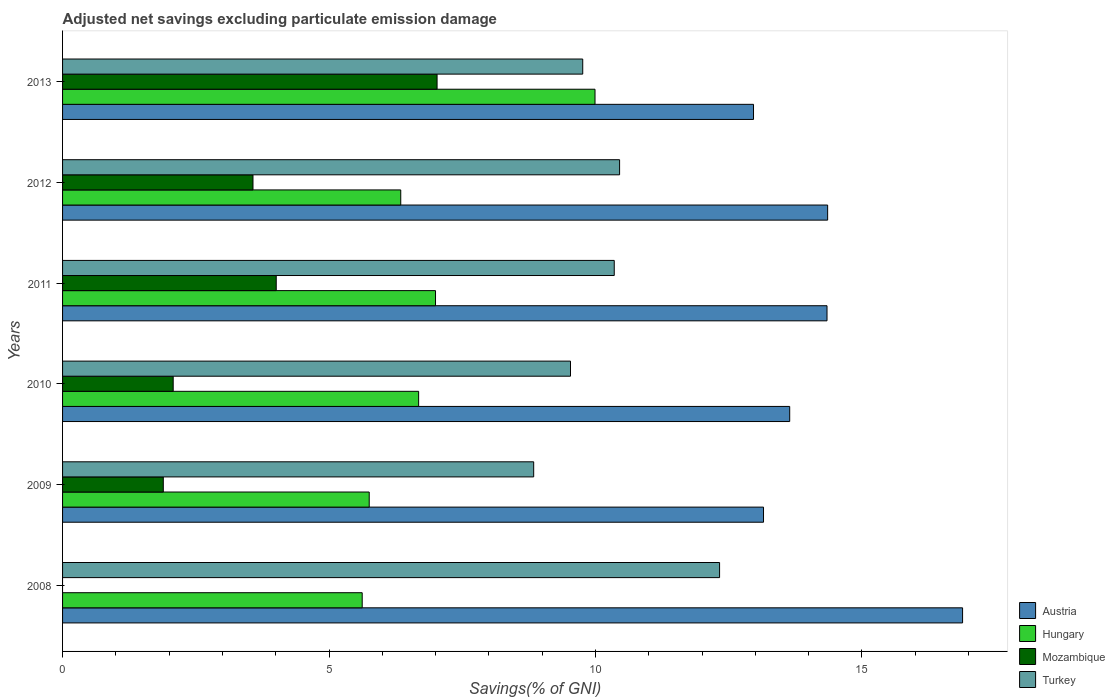How many different coloured bars are there?
Your answer should be very brief. 4. How many groups of bars are there?
Ensure brevity in your answer.  6. Are the number of bars on each tick of the Y-axis equal?
Your response must be concise. No. How many bars are there on the 4th tick from the top?
Your answer should be very brief. 4. How many bars are there on the 3rd tick from the bottom?
Make the answer very short. 4. What is the adjusted net savings in Hungary in 2012?
Make the answer very short. 6.35. Across all years, what is the maximum adjusted net savings in Mozambique?
Your response must be concise. 7.03. Across all years, what is the minimum adjusted net savings in Turkey?
Give a very brief answer. 8.84. In which year was the adjusted net savings in Mozambique maximum?
Offer a very short reply. 2013. What is the total adjusted net savings in Austria in the graph?
Keep it short and to the point. 85.36. What is the difference between the adjusted net savings in Austria in 2009 and that in 2012?
Your response must be concise. -1.2. What is the difference between the adjusted net savings in Austria in 2010 and the adjusted net savings in Mozambique in 2011?
Give a very brief answer. 9.64. What is the average adjusted net savings in Austria per year?
Provide a succinct answer. 14.23. In the year 2013, what is the difference between the adjusted net savings in Mozambique and adjusted net savings in Austria?
Your answer should be compact. -5.94. What is the ratio of the adjusted net savings in Mozambique in 2009 to that in 2011?
Provide a short and direct response. 0.47. Is the difference between the adjusted net savings in Mozambique in 2010 and 2013 greater than the difference between the adjusted net savings in Austria in 2010 and 2013?
Your response must be concise. No. What is the difference between the highest and the second highest adjusted net savings in Mozambique?
Provide a succinct answer. 3.02. What is the difference between the highest and the lowest adjusted net savings in Hungary?
Offer a very short reply. 4.37. In how many years, is the adjusted net savings in Hungary greater than the average adjusted net savings in Hungary taken over all years?
Keep it short and to the point. 2. Are all the bars in the graph horizontal?
Offer a very short reply. Yes. How many years are there in the graph?
Make the answer very short. 6. Are the values on the major ticks of X-axis written in scientific E-notation?
Offer a terse response. No. Where does the legend appear in the graph?
Your answer should be compact. Bottom right. How are the legend labels stacked?
Offer a very short reply. Vertical. What is the title of the graph?
Give a very brief answer. Adjusted net savings excluding particulate emission damage. What is the label or title of the X-axis?
Make the answer very short. Savings(% of GNI). What is the label or title of the Y-axis?
Your answer should be compact. Years. What is the Savings(% of GNI) in Austria in 2008?
Make the answer very short. 16.89. What is the Savings(% of GNI) in Hungary in 2008?
Give a very brief answer. 5.62. What is the Savings(% of GNI) in Mozambique in 2008?
Provide a short and direct response. 0. What is the Savings(% of GNI) of Turkey in 2008?
Your response must be concise. 12.33. What is the Savings(% of GNI) of Austria in 2009?
Your answer should be compact. 13.15. What is the Savings(% of GNI) of Hungary in 2009?
Ensure brevity in your answer.  5.75. What is the Savings(% of GNI) in Mozambique in 2009?
Provide a short and direct response. 1.89. What is the Savings(% of GNI) of Turkey in 2009?
Offer a very short reply. 8.84. What is the Savings(% of GNI) of Austria in 2010?
Provide a short and direct response. 13.64. What is the Savings(% of GNI) in Hungary in 2010?
Your answer should be very brief. 6.68. What is the Savings(% of GNI) in Mozambique in 2010?
Give a very brief answer. 2.08. What is the Savings(% of GNI) of Turkey in 2010?
Your response must be concise. 9.53. What is the Savings(% of GNI) of Austria in 2011?
Your answer should be very brief. 14.35. What is the Savings(% of GNI) in Hungary in 2011?
Ensure brevity in your answer.  7. What is the Savings(% of GNI) of Mozambique in 2011?
Make the answer very short. 4.01. What is the Savings(% of GNI) in Turkey in 2011?
Your answer should be compact. 10.35. What is the Savings(% of GNI) of Austria in 2012?
Give a very brief answer. 14.36. What is the Savings(% of GNI) of Hungary in 2012?
Offer a very short reply. 6.35. What is the Savings(% of GNI) in Mozambique in 2012?
Give a very brief answer. 3.57. What is the Savings(% of GNI) of Turkey in 2012?
Offer a terse response. 10.45. What is the Savings(% of GNI) of Austria in 2013?
Keep it short and to the point. 12.97. What is the Savings(% of GNI) of Hungary in 2013?
Ensure brevity in your answer.  9.99. What is the Savings(% of GNI) of Mozambique in 2013?
Ensure brevity in your answer.  7.03. What is the Savings(% of GNI) in Turkey in 2013?
Provide a short and direct response. 9.76. Across all years, what is the maximum Savings(% of GNI) in Austria?
Your response must be concise. 16.89. Across all years, what is the maximum Savings(% of GNI) in Hungary?
Offer a terse response. 9.99. Across all years, what is the maximum Savings(% of GNI) in Mozambique?
Offer a terse response. 7.03. Across all years, what is the maximum Savings(% of GNI) in Turkey?
Offer a terse response. 12.33. Across all years, what is the minimum Savings(% of GNI) of Austria?
Your answer should be compact. 12.97. Across all years, what is the minimum Savings(% of GNI) of Hungary?
Give a very brief answer. 5.62. Across all years, what is the minimum Savings(% of GNI) of Mozambique?
Make the answer very short. 0. Across all years, what is the minimum Savings(% of GNI) of Turkey?
Offer a terse response. 8.84. What is the total Savings(% of GNI) in Austria in the graph?
Keep it short and to the point. 85.36. What is the total Savings(% of GNI) in Hungary in the graph?
Ensure brevity in your answer.  41.4. What is the total Savings(% of GNI) in Mozambique in the graph?
Give a very brief answer. 18.58. What is the total Savings(% of GNI) in Turkey in the graph?
Your answer should be very brief. 61.27. What is the difference between the Savings(% of GNI) in Austria in 2008 and that in 2009?
Provide a short and direct response. 3.74. What is the difference between the Savings(% of GNI) in Hungary in 2008 and that in 2009?
Make the answer very short. -0.13. What is the difference between the Savings(% of GNI) of Turkey in 2008 and that in 2009?
Offer a terse response. 3.49. What is the difference between the Savings(% of GNI) in Austria in 2008 and that in 2010?
Offer a terse response. 3.24. What is the difference between the Savings(% of GNI) in Hungary in 2008 and that in 2010?
Provide a succinct answer. -1.06. What is the difference between the Savings(% of GNI) of Turkey in 2008 and that in 2010?
Provide a succinct answer. 2.8. What is the difference between the Savings(% of GNI) of Austria in 2008 and that in 2011?
Your answer should be compact. 2.54. What is the difference between the Savings(% of GNI) in Hungary in 2008 and that in 2011?
Make the answer very short. -1.38. What is the difference between the Savings(% of GNI) of Turkey in 2008 and that in 2011?
Keep it short and to the point. 1.98. What is the difference between the Savings(% of GNI) of Austria in 2008 and that in 2012?
Offer a very short reply. 2.53. What is the difference between the Savings(% of GNI) in Hungary in 2008 and that in 2012?
Make the answer very short. -0.72. What is the difference between the Savings(% of GNI) in Turkey in 2008 and that in 2012?
Keep it short and to the point. 1.88. What is the difference between the Savings(% of GNI) in Austria in 2008 and that in 2013?
Keep it short and to the point. 3.92. What is the difference between the Savings(% of GNI) in Hungary in 2008 and that in 2013?
Your response must be concise. -4.37. What is the difference between the Savings(% of GNI) of Turkey in 2008 and that in 2013?
Your answer should be compact. 2.57. What is the difference between the Savings(% of GNI) of Austria in 2009 and that in 2010?
Your response must be concise. -0.49. What is the difference between the Savings(% of GNI) in Hungary in 2009 and that in 2010?
Make the answer very short. -0.93. What is the difference between the Savings(% of GNI) in Mozambique in 2009 and that in 2010?
Ensure brevity in your answer.  -0.19. What is the difference between the Savings(% of GNI) in Turkey in 2009 and that in 2010?
Your answer should be compact. -0.69. What is the difference between the Savings(% of GNI) in Austria in 2009 and that in 2011?
Provide a succinct answer. -1.19. What is the difference between the Savings(% of GNI) in Hungary in 2009 and that in 2011?
Keep it short and to the point. -1.24. What is the difference between the Savings(% of GNI) in Mozambique in 2009 and that in 2011?
Offer a very short reply. -2.12. What is the difference between the Savings(% of GNI) of Turkey in 2009 and that in 2011?
Your answer should be very brief. -1.51. What is the difference between the Savings(% of GNI) of Austria in 2009 and that in 2012?
Give a very brief answer. -1.2. What is the difference between the Savings(% of GNI) in Hungary in 2009 and that in 2012?
Your answer should be compact. -0.59. What is the difference between the Savings(% of GNI) in Mozambique in 2009 and that in 2012?
Your answer should be compact. -1.68. What is the difference between the Savings(% of GNI) of Turkey in 2009 and that in 2012?
Make the answer very short. -1.61. What is the difference between the Savings(% of GNI) of Austria in 2009 and that in 2013?
Keep it short and to the point. 0.19. What is the difference between the Savings(% of GNI) in Hungary in 2009 and that in 2013?
Your answer should be very brief. -4.24. What is the difference between the Savings(% of GNI) of Mozambique in 2009 and that in 2013?
Provide a short and direct response. -5.14. What is the difference between the Savings(% of GNI) of Turkey in 2009 and that in 2013?
Ensure brevity in your answer.  -0.92. What is the difference between the Savings(% of GNI) in Austria in 2010 and that in 2011?
Offer a very short reply. -0.7. What is the difference between the Savings(% of GNI) of Hungary in 2010 and that in 2011?
Provide a succinct answer. -0.32. What is the difference between the Savings(% of GNI) in Mozambique in 2010 and that in 2011?
Your response must be concise. -1.93. What is the difference between the Savings(% of GNI) of Turkey in 2010 and that in 2011?
Your answer should be very brief. -0.82. What is the difference between the Savings(% of GNI) of Austria in 2010 and that in 2012?
Keep it short and to the point. -0.71. What is the difference between the Savings(% of GNI) of Hungary in 2010 and that in 2012?
Ensure brevity in your answer.  0.34. What is the difference between the Savings(% of GNI) of Mozambique in 2010 and that in 2012?
Your answer should be compact. -1.5. What is the difference between the Savings(% of GNI) in Turkey in 2010 and that in 2012?
Make the answer very short. -0.92. What is the difference between the Savings(% of GNI) in Austria in 2010 and that in 2013?
Offer a very short reply. 0.68. What is the difference between the Savings(% of GNI) of Hungary in 2010 and that in 2013?
Provide a short and direct response. -3.31. What is the difference between the Savings(% of GNI) of Mozambique in 2010 and that in 2013?
Ensure brevity in your answer.  -4.95. What is the difference between the Savings(% of GNI) in Turkey in 2010 and that in 2013?
Ensure brevity in your answer.  -0.23. What is the difference between the Savings(% of GNI) of Austria in 2011 and that in 2012?
Your response must be concise. -0.01. What is the difference between the Savings(% of GNI) of Hungary in 2011 and that in 2012?
Keep it short and to the point. 0.65. What is the difference between the Savings(% of GNI) of Mozambique in 2011 and that in 2012?
Your answer should be compact. 0.44. What is the difference between the Savings(% of GNI) in Turkey in 2011 and that in 2012?
Give a very brief answer. -0.1. What is the difference between the Savings(% of GNI) in Austria in 2011 and that in 2013?
Keep it short and to the point. 1.38. What is the difference between the Savings(% of GNI) of Hungary in 2011 and that in 2013?
Provide a short and direct response. -2.99. What is the difference between the Savings(% of GNI) of Mozambique in 2011 and that in 2013?
Offer a terse response. -3.02. What is the difference between the Savings(% of GNI) in Turkey in 2011 and that in 2013?
Give a very brief answer. 0.59. What is the difference between the Savings(% of GNI) in Austria in 2012 and that in 2013?
Make the answer very short. 1.39. What is the difference between the Savings(% of GNI) in Hungary in 2012 and that in 2013?
Provide a short and direct response. -3.65. What is the difference between the Savings(% of GNI) of Mozambique in 2012 and that in 2013?
Ensure brevity in your answer.  -3.45. What is the difference between the Savings(% of GNI) of Turkey in 2012 and that in 2013?
Make the answer very short. 0.69. What is the difference between the Savings(% of GNI) in Austria in 2008 and the Savings(% of GNI) in Hungary in 2009?
Offer a very short reply. 11.13. What is the difference between the Savings(% of GNI) of Austria in 2008 and the Savings(% of GNI) of Mozambique in 2009?
Offer a terse response. 15. What is the difference between the Savings(% of GNI) of Austria in 2008 and the Savings(% of GNI) of Turkey in 2009?
Your response must be concise. 8.05. What is the difference between the Savings(% of GNI) of Hungary in 2008 and the Savings(% of GNI) of Mozambique in 2009?
Give a very brief answer. 3.73. What is the difference between the Savings(% of GNI) in Hungary in 2008 and the Savings(% of GNI) in Turkey in 2009?
Make the answer very short. -3.22. What is the difference between the Savings(% of GNI) in Austria in 2008 and the Savings(% of GNI) in Hungary in 2010?
Provide a short and direct response. 10.21. What is the difference between the Savings(% of GNI) in Austria in 2008 and the Savings(% of GNI) in Mozambique in 2010?
Give a very brief answer. 14.81. What is the difference between the Savings(% of GNI) in Austria in 2008 and the Savings(% of GNI) in Turkey in 2010?
Provide a short and direct response. 7.36. What is the difference between the Savings(% of GNI) in Hungary in 2008 and the Savings(% of GNI) in Mozambique in 2010?
Make the answer very short. 3.55. What is the difference between the Savings(% of GNI) in Hungary in 2008 and the Savings(% of GNI) in Turkey in 2010?
Offer a very short reply. -3.91. What is the difference between the Savings(% of GNI) in Austria in 2008 and the Savings(% of GNI) in Hungary in 2011?
Ensure brevity in your answer.  9.89. What is the difference between the Savings(% of GNI) in Austria in 2008 and the Savings(% of GNI) in Mozambique in 2011?
Offer a very short reply. 12.88. What is the difference between the Savings(% of GNI) in Austria in 2008 and the Savings(% of GNI) in Turkey in 2011?
Your response must be concise. 6.54. What is the difference between the Savings(% of GNI) in Hungary in 2008 and the Savings(% of GNI) in Mozambique in 2011?
Give a very brief answer. 1.61. What is the difference between the Savings(% of GNI) of Hungary in 2008 and the Savings(% of GNI) of Turkey in 2011?
Your answer should be compact. -4.73. What is the difference between the Savings(% of GNI) of Austria in 2008 and the Savings(% of GNI) of Hungary in 2012?
Give a very brief answer. 10.54. What is the difference between the Savings(% of GNI) of Austria in 2008 and the Savings(% of GNI) of Mozambique in 2012?
Your answer should be very brief. 13.32. What is the difference between the Savings(% of GNI) in Austria in 2008 and the Savings(% of GNI) in Turkey in 2012?
Ensure brevity in your answer.  6.44. What is the difference between the Savings(% of GNI) in Hungary in 2008 and the Savings(% of GNI) in Mozambique in 2012?
Provide a succinct answer. 2.05. What is the difference between the Savings(% of GNI) of Hungary in 2008 and the Savings(% of GNI) of Turkey in 2012?
Keep it short and to the point. -4.83. What is the difference between the Savings(% of GNI) of Austria in 2008 and the Savings(% of GNI) of Hungary in 2013?
Your answer should be compact. 6.9. What is the difference between the Savings(% of GNI) in Austria in 2008 and the Savings(% of GNI) in Mozambique in 2013?
Your answer should be compact. 9.86. What is the difference between the Savings(% of GNI) in Austria in 2008 and the Savings(% of GNI) in Turkey in 2013?
Your answer should be very brief. 7.13. What is the difference between the Savings(% of GNI) of Hungary in 2008 and the Savings(% of GNI) of Mozambique in 2013?
Offer a terse response. -1.41. What is the difference between the Savings(% of GNI) in Hungary in 2008 and the Savings(% of GNI) in Turkey in 2013?
Provide a short and direct response. -4.14. What is the difference between the Savings(% of GNI) in Austria in 2009 and the Savings(% of GNI) in Hungary in 2010?
Your answer should be very brief. 6.47. What is the difference between the Savings(% of GNI) of Austria in 2009 and the Savings(% of GNI) of Mozambique in 2010?
Provide a succinct answer. 11.08. What is the difference between the Savings(% of GNI) of Austria in 2009 and the Savings(% of GNI) of Turkey in 2010?
Offer a terse response. 3.62. What is the difference between the Savings(% of GNI) of Hungary in 2009 and the Savings(% of GNI) of Mozambique in 2010?
Give a very brief answer. 3.68. What is the difference between the Savings(% of GNI) of Hungary in 2009 and the Savings(% of GNI) of Turkey in 2010?
Ensure brevity in your answer.  -3.78. What is the difference between the Savings(% of GNI) in Mozambique in 2009 and the Savings(% of GNI) in Turkey in 2010?
Keep it short and to the point. -7.64. What is the difference between the Savings(% of GNI) of Austria in 2009 and the Savings(% of GNI) of Hungary in 2011?
Offer a very short reply. 6.16. What is the difference between the Savings(% of GNI) of Austria in 2009 and the Savings(% of GNI) of Mozambique in 2011?
Your response must be concise. 9.14. What is the difference between the Savings(% of GNI) in Austria in 2009 and the Savings(% of GNI) in Turkey in 2011?
Make the answer very short. 2.8. What is the difference between the Savings(% of GNI) in Hungary in 2009 and the Savings(% of GNI) in Mozambique in 2011?
Your answer should be very brief. 1.74. What is the difference between the Savings(% of GNI) in Hungary in 2009 and the Savings(% of GNI) in Turkey in 2011?
Your response must be concise. -4.6. What is the difference between the Savings(% of GNI) of Mozambique in 2009 and the Savings(% of GNI) of Turkey in 2011?
Make the answer very short. -8.46. What is the difference between the Savings(% of GNI) of Austria in 2009 and the Savings(% of GNI) of Hungary in 2012?
Make the answer very short. 6.81. What is the difference between the Savings(% of GNI) in Austria in 2009 and the Savings(% of GNI) in Mozambique in 2012?
Your answer should be compact. 9.58. What is the difference between the Savings(% of GNI) of Austria in 2009 and the Savings(% of GNI) of Turkey in 2012?
Your answer should be very brief. 2.7. What is the difference between the Savings(% of GNI) of Hungary in 2009 and the Savings(% of GNI) of Mozambique in 2012?
Your answer should be compact. 2.18. What is the difference between the Savings(% of GNI) in Hungary in 2009 and the Savings(% of GNI) in Turkey in 2012?
Your answer should be very brief. -4.7. What is the difference between the Savings(% of GNI) in Mozambique in 2009 and the Savings(% of GNI) in Turkey in 2012?
Ensure brevity in your answer.  -8.56. What is the difference between the Savings(% of GNI) of Austria in 2009 and the Savings(% of GNI) of Hungary in 2013?
Offer a terse response. 3.16. What is the difference between the Savings(% of GNI) in Austria in 2009 and the Savings(% of GNI) in Mozambique in 2013?
Your answer should be compact. 6.13. What is the difference between the Savings(% of GNI) in Austria in 2009 and the Savings(% of GNI) in Turkey in 2013?
Offer a terse response. 3.39. What is the difference between the Savings(% of GNI) in Hungary in 2009 and the Savings(% of GNI) in Mozambique in 2013?
Your answer should be very brief. -1.27. What is the difference between the Savings(% of GNI) in Hungary in 2009 and the Savings(% of GNI) in Turkey in 2013?
Your response must be concise. -4.01. What is the difference between the Savings(% of GNI) of Mozambique in 2009 and the Savings(% of GNI) of Turkey in 2013?
Offer a terse response. -7.87. What is the difference between the Savings(% of GNI) in Austria in 2010 and the Savings(% of GNI) in Hungary in 2011?
Ensure brevity in your answer.  6.65. What is the difference between the Savings(% of GNI) in Austria in 2010 and the Savings(% of GNI) in Mozambique in 2011?
Offer a very short reply. 9.64. What is the difference between the Savings(% of GNI) of Austria in 2010 and the Savings(% of GNI) of Turkey in 2011?
Provide a succinct answer. 3.29. What is the difference between the Savings(% of GNI) of Hungary in 2010 and the Savings(% of GNI) of Mozambique in 2011?
Offer a terse response. 2.67. What is the difference between the Savings(% of GNI) of Hungary in 2010 and the Savings(% of GNI) of Turkey in 2011?
Give a very brief answer. -3.67. What is the difference between the Savings(% of GNI) of Mozambique in 2010 and the Savings(% of GNI) of Turkey in 2011?
Provide a short and direct response. -8.28. What is the difference between the Savings(% of GNI) in Austria in 2010 and the Savings(% of GNI) in Hungary in 2012?
Keep it short and to the point. 7.3. What is the difference between the Savings(% of GNI) in Austria in 2010 and the Savings(% of GNI) in Mozambique in 2012?
Your answer should be compact. 10.07. What is the difference between the Savings(% of GNI) of Austria in 2010 and the Savings(% of GNI) of Turkey in 2012?
Keep it short and to the point. 3.19. What is the difference between the Savings(% of GNI) in Hungary in 2010 and the Savings(% of GNI) in Mozambique in 2012?
Offer a very short reply. 3.11. What is the difference between the Savings(% of GNI) of Hungary in 2010 and the Savings(% of GNI) of Turkey in 2012?
Your response must be concise. -3.77. What is the difference between the Savings(% of GNI) of Mozambique in 2010 and the Savings(% of GNI) of Turkey in 2012?
Make the answer very short. -8.38. What is the difference between the Savings(% of GNI) in Austria in 2010 and the Savings(% of GNI) in Hungary in 2013?
Your response must be concise. 3.65. What is the difference between the Savings(% of GNI) of Austria in 2010 and the Savings(% of GNI) of Mozambique in 2013?
Provide a succinct answer. 6.62. What is the difference between the Savings(% of GNI) in Austria in 2010 and the Savings(% of GNI) in Turkey in 2013?
Ensure brevity in your answer.  3.88. What is the difference between the Savings(% of GNI) in Hungary in 2010 and the Savings(% of GNI) in Mozambique in 2013?
Give a very brief answer. -0.35. What is the difference between the Savings(% of GNI) in Hungary in 2010 and the Savings(% of GNI) in Turkey in 2013?
Your answer should be very brief. -3.08. What is the difference between the Savings(% of GNI) in Mozambique in 2010 and the Savings(% of GNI) in Turkey in 2013?
Give a very brief answer. -7.69. What is the difference between the Savings(% of GNI) in Austria in 2011 and the Savings(% of GNI) in Hungary in 2012?
Keep it short and to the point. 8. What is the difference between the Savings(% of GNI) in Austria in 2011 and the Savings(% of GNI) in Mozambique in 2012?
Your response must be concise. 10.77. What is the difference between the Savings(% of GNI) in Austria in 2011 and the Savings(% of GNI) in Turkey in 2012?
Your response must be concise. 3.89. What is the difference between the Savings(% of GNI) of Hungary in 2011 and the Savings(% of GNI) of Mozambique in 2012?
Ensure brevity in your answer.  3.43. What is the difference between the Savings(% of GNI) of Hungary in 2011 and the Savings(% of GNI) of Turkey in 2012?
Make the answer very short. -3.45. What is the difference between the Savings(% of GNI) of Mozambique in 2011 and the Savings(% of GNI) of Turkey in 2012?
Your answer should be very brief. -6.44. What is the difference between the Savings(% of GNI) in Austria in 2011 and the Savings(% of GNI) in Hungary in 2013?
Your answer should be compact. 4.35. What is the difference between the Savings(% of GNI) in Austria in 2011 and the Savings(% of GNI) in Mozambique in 2013?
Ensure brevity in your answer.  7.32. What is the difference between the Savings(% of GNI) in Austria in 2011 and the Savings(% of GNI) in Turkey in 2013?
Your answer should be very brief. 4.58. What is the difference between the Savings(% of GNI) of Hungary in 2011 and the Savings(% of GNI) of Mozambique in 2013?
Your answer should be compact. -0.03. What is the difference between the Savings(% of GNI) in Hungary in 2011 and the Savings(% of GNI) in Turkey in 2013?
Give a very brief answer. -2.76. What is the difference between the Savings(% of GNI) of Mozambique in 2011 and the Savings(% of GNI) of Turkey in 2013?
Make the answer very short. -5.75. What is the difference between the Savings(% of GNI) in Austria in 2012 and the Savings(% of GNI) in Hungary in 2013?
Make the answer very short. 4.37. What is the difference between the Savings(% of GNI) in Austria in 2012 and the Savings(% of GNI) in Mozambique in 2013?
Keep it short and to the point. 7.33. What is the difference between the Savings(% of GNI) of Austria in 2012 and the Savings(% of GNI) of Turkey in 2013?
Offer a terse response. 4.6. What is the difference between the Savings(% of GNI) in Hungary in 2012 and the Savings(% of GNI) in Mozambique in 2013?
Provide a succinct answer. -0.68. What is the difference between the Savings(% of GNI) in Hungary in 2012 and the Savings(% of GNI) in Turkey in 2013?
Ensure brevity in your answer.  -3.41. What is the difference between the Savings(% of GNI) in Mozambique in 2012 and the Savings(% of GNI) in Turkey in 2013?
Keep it short and to the point. -6.19. What is the average Savings(% of GNI) in Austria per year?
Your answer should be compact. 14.23. What is the average Savings(% of GNI) in Hungary per year?
Offer a very short reply. 6.9. What is the average Savings(% of GNI) in Mozambique per year?
Give a very brief answer. 3.1. What is the average Savings(% of GNI) in Turkey per year?
Make the answer very short. 10.21. In the year 2008, what is the difference between the Savings(% of GNI) in Austria and Savings(% of GNI) in Hungary?
Make the answer very short. 11.27. In the year 2008, what is the difference between the Savings(% of GNI) in Austria and Savings(% of GNI) in Turkey?
Provide a succinct answer. 4.56. In the year 2008, what is the difference between the Savings(% of GNI) in Hungary and Savings(% of GNI) in Turkey?
Offer a terse response. -6.71. In the year 2009, what is the difference between the Savings(% of GNI) of Austria and Savings(% of GNI) of Hungary?
Make the answer very short. 7.4. In the year 2009, what is the difference between the Savings(% of GNI) in Austria and Savings(% of GNI) in Mozambique?
Provide a short and direct response. 11.26. In the year 2009, what is the difference between the Savings(% of GNI) in Austria and Savings(% of GNI) in Turkey?
Give a very brief answer. 4.31. In the year 2009, what is the difference between the Savings(% of GNI) in Hungary and Savings(% of GNI) in Mozambique?
Your answer should be compact. 3.86. In the year 2009, what is the difference between the Savings(% of GNI) in Hungary and Savings(% of GNI) in Turkey?
Your response must be concise. -3.09. In the year 2009, what is the difference between the Savings(% of GNI) of Mozambique and Savings(% of GNI) of Turkey?
Your response must be concise. -6.95. In the year 2010, what is the difference between the Savings(% of GNI) in Austria and Savings(% of GNI) in Hungary?
Offer a very short reply. 6.96. In the year 2010, what is the difference between the Savings(% of GNI) of Austria and Savings(% of GNI) of Mozambique?
Provide a short and direct response. 11.57. In the year 2010, what is the difference between the Savings(% of GNI) of Austria and Savings(% of GNI) of Turkey?
Your answer should be very brief. 4.11. In the year 2010, what is the difference between the Savings(% of GNI) of Hungary and Savings(% of GNI) of Mozambique?
Offer a very short reply. 4.61. In the year 2010, what is the difference between the Savings(% of GNI) of Hungary and Savings(% of GNI) of Turkey?
Your answer should be very brief. -2.85. In the year 2010, what is the difference between the Savings(% of GNI) of Mozambique and Savings(% of GNI) of Turkey?
Ensure brevity in your answer.  -7.46. In the year 2011, what is the difference between the Savings(% of GNI) of Austria and Savings(% of GNI) of Hungary?
Your answer should be very brief. 7.35. In the year 2011, what is the difference between the Savings(% of GNI) of Austria and Savings(% of GNI) of Mozambique?
Ensure brevity in your answer.  10.34. In the year 2011, what is the difference between the Savings(% of GNI) of Austria and Savings(% of GNI) of Turkey?
Offer a terse response. 3.99. In the year 2011, what is the difference between the Savings(% of GNI) of Hungary and Savings(% of GNI) of Mozambique?
Make the answer very short. 2.99. In the year 2011, what is the difference between the Savings(% of GNI) in Hungary and Savings(% of GNI) in Turkey?
Your response must be concise. -3.35. In the year 2011, what is the difference between the Savings(% of GNI) in Mozambique and Savings(% of GNI) in Turkey?
Provide a succinct answer. -6.34. In the year 2012, what is the difference between the Savings(% of GNI) of Austria and Savings(% of GNI) of Hungary?
Provide a succinct answer. 8.01. In the year 2012, what is the difference between the Savings(% of GNI) in Austria and Savings(% of GNI) in Mozambique?
Provide a succinct answer. 10.78. In the year 2012, what is the difference between the Savings(% of GNI) in Austria and Savings(% of GNI) in Turkey?
Your response must be concise. 3.9. In the year 2012, what is the difference between the Savings(% of GNI) in Hungary and Savings(% of GNI) in Mozambique?
Ensure brevity in your answer.  2.77. In the year 2012, what is the difference between the Savings(% of GNI) of Hungary and Savings(% of GNI) of Turkey?
Your response must be concise. -4.11. In the year 2012, what is the difference between the Savings(% of GNI) of Mozambique and Savings(% of GNI) of Turkey?
Your response must be concise. -6.88. In the year 2013, what is the difference between the Savings(% of GNI) in Austria and Savings(% of GNI) in Hungary?
Make the answer very short. 2.97. In the year 2013, what is the difference between the Savings(% of GNI) in Austria and Savings(% of GNI) in Mozambique?
Your answer should be very brief. 5.94. In the year 2013, what is the difference between the Savings(% of GNI) in Austria and Savings(% of GNI) in Turkey?
Offer a terse response. 3.2. In the year 2013, what is the difference between the Savings(% of GNI) in Hungary and Savings(% of GNI) in Mozambique?
Provide a succinct answer. 2.96. In the year 2013, what is the difference between the Savings(% of GNI) in Hungary and Savings(% of GNI) in Turkey?
Ensure brevity in your answer.  0.23. In the year 2013, what is the difference between the Savings(% of GNI) of Mozambique and Savings(% of GNI) of Turkey?
Your answer should be compact. -2.73. What is the ratio of the Savings(% of GNI) in Austria in 2008 to that in 2009?
Make the answer very short. 1.28. What is the ratio of the Savings(% of GNI) of Hungary in 2008 to that in 2009?
Ensure brevity in your answer.  0.98. What is the ratio of the Savings(% of GNI) of Turkey in 2008 to that in 2009?
Offer a very short reply. 1.39. What is the ratio of the Savings(% of GNI) in Austria in 2008 to that in 2010?
Your answer should be compact. 1.24. What is the ratio of the Savings(% of GNI) in Hungary in 2008 to that in 2010?
Provide a short and direct response. 0.84. What is the ratio of the Savings(% of GNI) of Turkey in 2008 to that in 2010?
Provide a short and direct response. 1.29. What is the ratio of the Savings(% of GNI) of Austria in 2008 to that in 2011?
Your response must be concise. 1.18. What is the ratio of the Savings(% of GNI) of Hungary in 2008 to that in 2011?
Your answer should be very brief. 0.8. What is the ratio of the Savings(% of GNI) of Turkey in 2008 to that in 2011?
Keep it short and to the point. 1.19. What is the ratio of the Savings(% of GNI) of Austria in 2008 to that in 2012?
Your response must be concise. 1.18. What is the ratio of the Savings(% of GNI) of Hungary in 2008 to that in 2012?
Give a very brief answer. 0.89. What is the ratio of the Savings(% of GNI) in Turkey in 2008 to that in 2012?
Offer a terse response. 1.18. What is the ratio of the Savings(% of GNI) of Austria in 2008 to that in 2013?
Provide a short and direct response. 1.3. What is the ratio of the Savings(% of GNI) in Hungary in 2008 to that in 2013?
Ensure brevity in your answer.  0.56. What is the ratio of the Savings(% of GNI) of Turkey in 2008 to that in 2013?
Offer a terse response. 1.26. What is the ratio of the Savings(% of GNI) in Austria in 2009 to that in 2010?
Make the answer very short. 0.96. What is the ratio of the Savings(% of GNI) of Hungary in 2009 to that in 2010?
Offer a very short reply. 0.86. What is the ratio of the Savings(% of GNI) of Mozambique in 2009 to that in 2010?
Your response must be concise. 0.91. What is the ratio of the Savings(% of GNI) in Turkey in 2009 to that in 2010?
Ensure brevity in your answer.  0.93. What is the ratio of the Savings(% of GNI) of Austria in 2009 to that in 2011?
Your response must be concise. 0.92. What is the ratio of the Savings(% of GNI) in Hungary in 2009 to that in 2011?
Ensure brevity in your answer.  0.82. What is the ratio of the Savings(% of GNI) in Mozambique in 2009 to that in 2011?
Offer a terse response. 0.47. What is the ratio of the Savings(% of GNI) in Turkey in 2009 to that in 2011?
Ensure brevity in your answer.  0.85. What is the ratio of the Savings(% of GNI) in Austria in 2009 to that in 2012?
Offer a terse response. 0.92. What is the ratio of the Savings(% of GNI) in Hungary in 2009 to that in 2012?
Keep it short and to the point. 0.91. What is the ratio of the Savings(% of GNI) in Mozambique in 2009 to that in 2012?
Your answer should be very brief. 0.53. What is the ratio of the Savings(% of GNI) of Turkey in 2009 to that in 2012?
Keep it short and to the point. 0.85. What is the ratio of the Savings(% of GNI) of Austria in 2009 to that in 2013?
Your answer should be very brief. 1.01. What is the ratio of the Savings(% of GNI) in Hungary in 2009 to that in 2013?
Provide a succinct answer. 0.58. What is the ratio of the Savings(% of GNI) in Mozambique in 2009 to that in 2013?
Ensure brevity in your answer.  0.27. What is the ratio of the Savings(% of GNI) in Turkey in 2009 to that in 2013?
Offer a terse response. 0.91. What is the ratio of the Savings(% of GNI) of Austria in 2010 to that in 2011?
Make the answer very short. 0.95. What is the ratio of the Savings(% of GNI) of Hungary in 2010 to that in 2011?
Keep it short and to the point. 0.95. What is the ratio of the Savings(% of GNI) of Mozambique in 2010 to that in 2011?
Keep it short and to the point. 0.52. What is the ratio of the Savings(% of GNI) of Turkey in 2010 to that in 2011?
Your response must be concise. 0.92. What is the ratio of the Savings(% of GNI) of Austria in 2010 to that in 2012?
Give a very brief answer. 0.95. What is the ratio of the Savings(% of GNI) of Hungary in 2010 to that in 2012?
Give a very brief answer. 1.05. What is the ratio of the Savings(% of GNI) of Mozambique in 2010 to that in 2012?
Provide a succinct answer. 0.58. What is the ratio of the Savings(% of GNI) in Turkey in 2010 to that in 2012?
Provide a short and direct response. 0.91. What is the ratio of the Savings(% of GNI) in Austria in 2010 to that in 2013?
Give a very brief answer. 1.05. What is the ratio of the Savings(% of GNI) in Hungary in 2010 to that in 2013?
Your answer should be compact. 0.67. What is the ratio of the Savings(% of GNI) in Mozambique in 2010 to that in 2013?
Provide a succinct answer. 0.3. What is the ratio of the Savings(% of GNI) in Turkey in 2010 to that in 2013?
Your answer should be very brief. 0.98. What is the ratio of the Savings(% of GNI) in Austria in 2011 to that in 2012?
Keep it short and to the point. 1. What is the ratio of the Savings(% of GNI) of Hungary in 2011 to that in 2012?
Give a very brief answer. 1.1. What is the ratio of the Savings(% of GNI) of Mozambique in 2011 to that in 2012?
Your answer should be very brief. 1.12. What is the ratio of the Savings(% of GNI) in Austria in 2011 to that in 2013?
Your response must be concise. 1.11. What is the ratio of the Savings(% of GNI) in Hungary in 2011 to that in 2013?
Your answer should be very brief. 0.7. What is the ratio of the Savings(% of GNI) in Mozambique in 2011 to that in 2013?
Your response must be concise. 0.57. What is the ratio of the Savings(% of GNI) in Turkey in 2011 to that in 2013?
Offer a very short reply. 1.06. What is the ratio of the Savings(% of GNI) of Austria in 2012 to that in 2013?
Offer a terse response. 1.11. What is the ratio of the Savings(% of GNI) of Hungary in 2012 to that in 2013?
Provide a short and direct response. 0.64. What is the ratio of the Savings(% of GNI) of Mozambique in 2012 to that in 2013?
Provide a short and direct response. 0.51. What is the ratio of the Savings(% of GNI) of Turkey in 2012 to that in 2013?
Offer a very short reply. 1.07. What is the difference between the highest and the second highest Savings(% of GNI) in Austria?
Offer a terse response. 2.53. What is the difference between the highest and the second highest Savings(% of GNI) of Hungary?
Provide a short and direct response. 2.99. What is the difference between the highest and the second highest Savings(% of GNI) of Mozambique?
Provide a succinct answer. 3.02. What is the difference between the highest and the second highest Savings(% of GNI) of Turkey?
Your answer should be very brief. 1.88. What is the difference between the highest and the lowest Savings(% of GNI) of Austria?
Ensure brevity in your answer.  3.92. What is the difference between the highest and the lowest Savings(% of GNI) of Hungary?
Provide a short and direct response. 4.37. What is the difference between the highest and the lowest Savings(% of GNI) in Mozambique?
Your answer should be very brief. 7.03. What is the difference between the highest and the lowest Savings(% of GNI) in Turkey?
Keep it short and to the point. 3.49. 